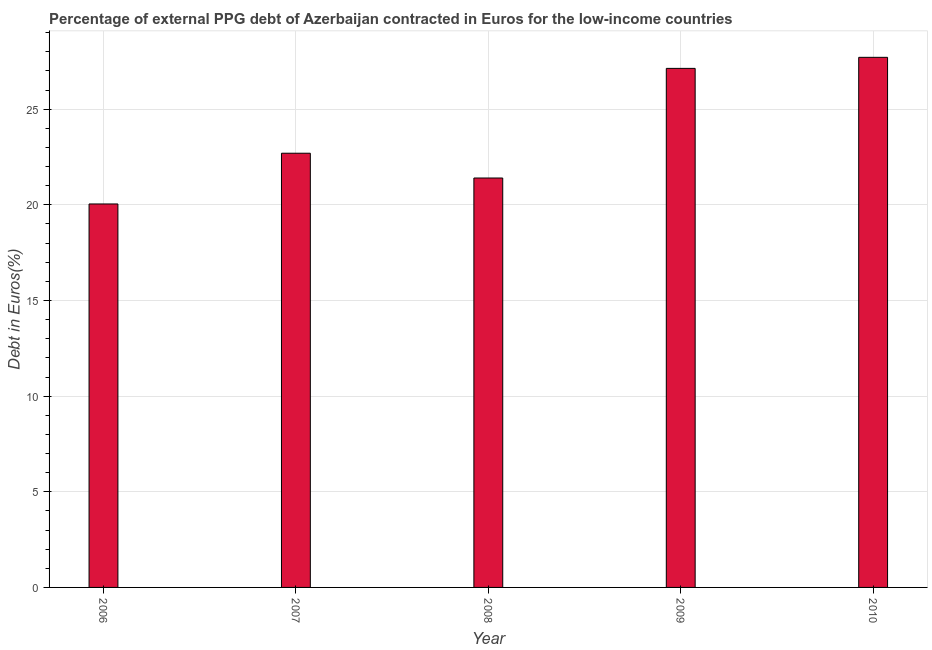What is the title of the graph?
Ensure brevity in your answer.  Percentage of external PPG debt of Azerbaijan contracted in Euros for the low-income countries. What is the label or title of the X-axis?
Your response must be concise. Year. What is the label or title of the Y-axis?
Ensure brevity in your answer.  Debt in Euros(%). What is the currency composition of ppg debt in 2007?
Your response must be concise. 22.7. Across all years, what is the maximum currency composition of ppg debt?
Provide a short and direct response. 27.71. Across all years, what is the minimum currency composition of ppg debt?
Your answer should be very brief. 20.05. In which year was the currency composition of ppg debt maximum?
Give a very brief answer. 2010. What is the sum of the currency composition of ppg debt?
Your answer should be compact. 118.99. What is the difference between the currency composition of ppg debt in 2007 and 2008?
Your answer should be compact. 1.3. What is the average currency composition of ppg debt per year?
Ensure brevity in your answer.  23.8. What is the median currency composition of ppg debt?
Make the answer very short. 22.7. Do a majority of the years between 2008 and 2009 (inclusive) have currency composition of ppg debt greater than 26 %?
Ensure brevity in your answer.  No. What is the ratio of the currency composition of ppg debt in 2006 to that in 2010?
Your response must be concise. 0.72. Is the currency composition of ppg debt in 2007 less than that in 2009?
Make the answer very short. Yes. What is the difference between the highest and the second highest currency composition of ppg debt?
Keep it short and to the point. 0.58. What is the difference between the highest and the lowest currency composition of ppg debt?
Provide a succinct answer. 7.67. In how many years, is the currency composition of ppg debt greater than the average currency composition of ppg debt taken over all years?
Ensure brevity in your answer.  2. How many years are there in the graph?
Offer a very short reply. 5. What is the difference between two consecutive major ticks on the Y-axis?
Offer a terse response. 5. What is the Debt in Euros(%) in 2006?
Make the answer very short. 20.05. What is the Debt in Euros(%) in 2007?
Your answer should be very brief. 22.7. What is the Debt in Euros(%) in 2008?
Give a very brief answer. 21.4. What is the Debt in Euros(%) in 2009?
Make the answer very short. 27.13. What is the Debt in Euros(%) in 2010?
Your answer should be compact. 27.71. What is the difference between the Debt in Euros(%) in 2006 and 2007?
Keep it short and to the point. -2.65. What is the difference between the Debt in Euros(%) in 2006 and 2008?
Provide a succinct answer. -1.36. What is the difference between the Debt in Euros(%) in 2006 and 2009?
Your answer should be very brief. -7.09. What is the difference between the Debt in Euros(%) in 2006 and 2010?
Your response must be concise. -7.67. What is the difference between the Debt in Euros(%) in 2007 and 2008?
Your answer should be very brief. 1.3. What is the difference between the Debt in Euros(%) in 2007 and 2009?
Offer a very short reply. -4.43. What is the difference between the Debt in Euros(%) in 2007 and 2010?
Your answer should be very brief. -5.01. What is the difference between the Debt in Euros(%) in 2008 and 2009?
Offer a terse response. -5.73. What is the difference between the Debt in Euros(%) in 2008 and 2010?
Provide a short and direct response. -6.31. What is the difference between the Debt in Euros(%) in 2009 and 2010?
Give a very brief answer. -0.58. What is the ratio of the Debt in Euros(%) in 2006 to that in 2007?
Offer a very short reply. 0.88. What is the ratio of the Debt in Euros(%) in 2006 to that in 2008?
Provide a short and direct response. 0.94. What is the ratio of the Debt in Euros(%) in 2006 to that in 2009?
Your answer should be very brief. 0.74. What is the ratio of the Debt in Euros(%) in 2006 to that in 2010?
Ensure brevity in your answer.  0.72. What is the ratio of the Debt in Euros(%) in 2007 to that in 2008?
Offer a terse response. 1.06. What is the ratio of the Debt in Euros(%) in 2007 to that in 2009?
Ensure brevity in your answer.  0.84. What is the ratio of the Debt in Euros(%) in 2007 to that in 2010?
Your answer should be compact. 0.82. What is the ratio of the Debt in Euros(%) in 2008 to that in 2009?
Offer a very short reply. 0.79. What is the ratio of the Debt in Euros(%) in 2008 to that in 2010?
Offer a very short reply. 0.77. 